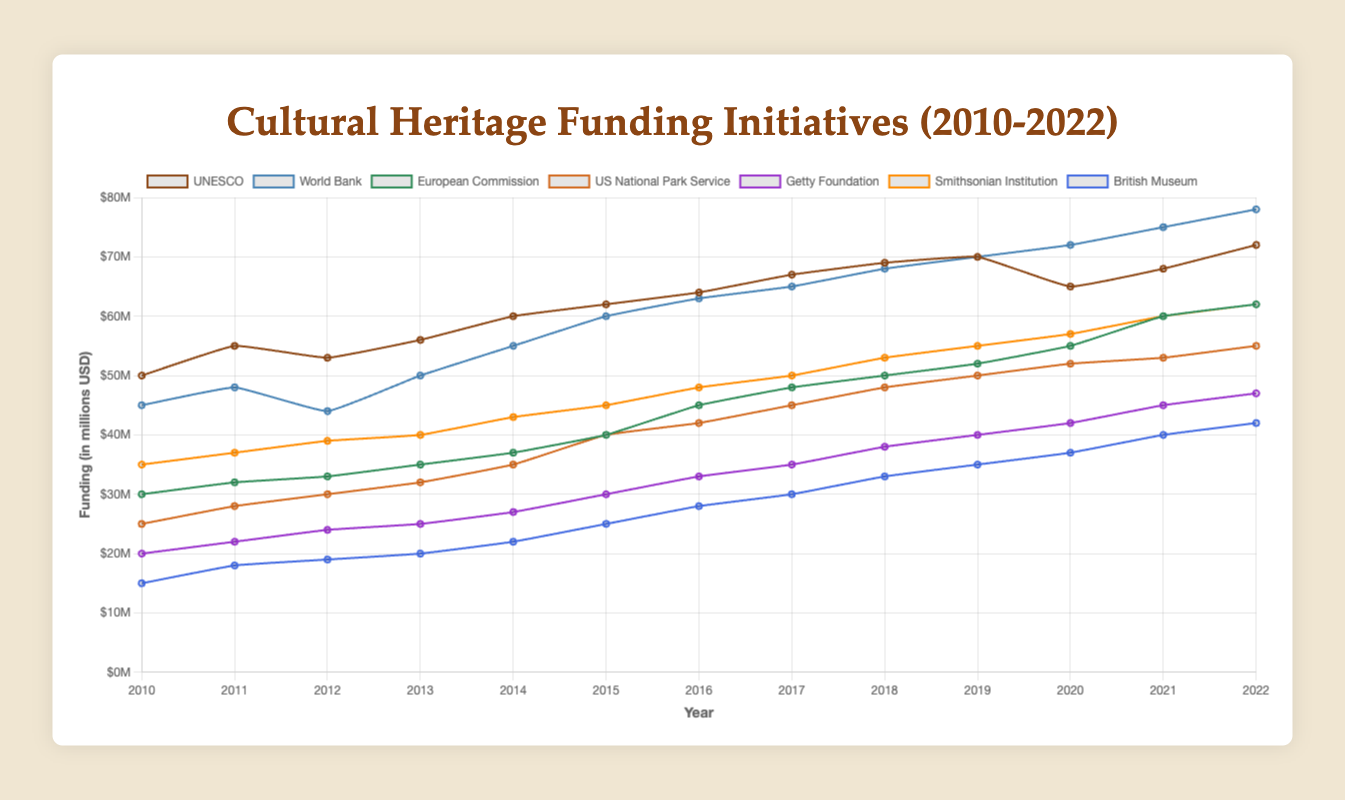What is the total funding allocated by UNESCO in 2022? According to the figure, the funding allocated by UNESCO in 2022 is indicated by the height of its line plot. The value corresponds to 72 million USD.
Answer: 72 million USD Which organization had the largest increase in funding from 2010 to 2022? To find this, compare the funding values in 2010 and 2022 for each organization and determine the increase. The World Bank had an increase from 45 million USD in 2010 to 78 million USD in 2022, which is an increase of 33 million USD. This is the largest among all organizations.
Answer: World Bank How did the funding from the Getty Foundation change between 2015 and 2020? The figure shows that the Getty Foundation's funding increased from 30 million USD in 2015 to 42 million USD in 2020.
Answer: Increased by 12 million USD Which organizations' funding surpasses 60 million USD in 2022? Observing the figure, the organizations with funding above 60 million USD in 2022 are UNESCO, World Bank, European Commission, Smithsonian Institution.
Answer: UNESCO, World Bank, European Commission, Smithsonian Institution What is the average funding allocated by the British Museum from 2010 to 2022? Calculate the sum of the British Museum's funding over the years (15 + 18 + 19 + 20 + 22 + 25 + 28 + 30 + 33 + 35 + 37 + 40 + 42 = 364 million USD) and then divide by the number of years (13). The average is 364/13 ≈ 28 million USD.
Answer: 28 million USD Which organization had the second lowest funding in 2015? Referring to the figure for 2015, the funding amounts are: UNESCO (62), World Bank (60), European Commission (40), US National Park Service (40), Getty Foundation (30), Smithsonian Institution (45), and British Museum (25). The second-lowest funding amount is 30 million USD from the Getty Foundation.
Answer: Getty Foundation Between World Bank and US National Park Service, which had a higher funding increase from 2013 to 2017? For World Bank, funding increased from 50 million USD in 2013 to 65 million USD in 2017, an increase of 15 million USD. For US National Park Service, funding increased from 32 million USD in 2013 to 45 million USD in 2017, an increase of 13 million USD. Therefore, World Bank had a higher increase.
Answer: World Bank In which year did the funding from Smithsonian Institution first reach 50 million USD? Observing the line plot for Smithsonian Institution, the first year the funding reached 50 million USD was in 2017.
Answer: 2017 What's the highest funding amount for European Commission between 2010 and 2022? The highest point on the line plot for European Commission represents its highest funding amount, which is 62 million USD in 2022.
Answer: 62 million USD Compare the funding trends of World Bank and British Museum from 2010 to 2022. World Bank funding shows a consistent increasing trend from 45 million USD in 2010 to 78 million USD in 2022. British Museum also shows an increasing trend but starts lower at 15 million USD in 2010 and reaches 42 million USD in 2022. The slope of increase for World Bank is steeper compared to British Museum.
Answer: Both increased; World Bank increased more rapidly 